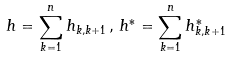Convert formula to latex. <formula><loc_0><loc_0><loc_500><loc_500>h = \sum _ { k = 1 } ^ { n } h _ { k , k + 1 \, } , \, h ^ { \ast } = \sum _ { k = 1 } ^ { n } h _ { k , k + 1 \, } ^ { \ast }</formula> 